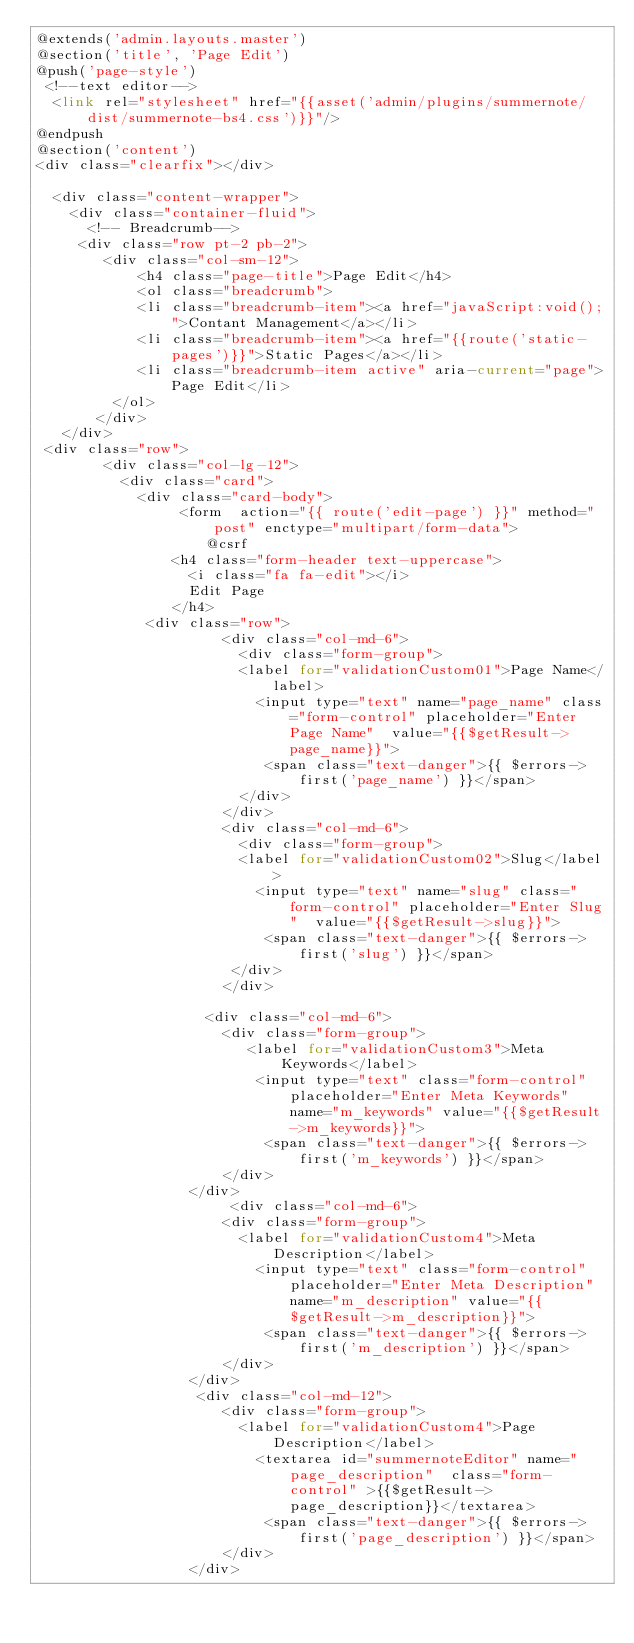Convert code to text. <code><loc_0><loc_0><loc_500><loc_500><_PHP_>@extends('admin.layouts.master')
@section('title', 'Page Edit')
@push('page-style')
 <!--text editor-->
  <link rel="stylesheet" href="{{asset('admin/plugins/summernote/dist/summernote-bs4.css')}}"/> 
@endpush
@section('content')
<div class="clearfix"></div>
	
  <div class="content-wrapper">
    <div class="container-fluid">
      <!-- Breadcrumb-->
     <div class="row pt-2 pb-2">
        <div class="col-sm-12">
		    <h4 class="page-title">Page Edit</h4>
		    <ol class="breadcrumb">
            <li class="breadcrumb-item"><a href="javaScript:void();">Contant Management</a></li>
            <li class="breadcrumb-item"><a href="{{route('static-pages')}}">Static Pages</a></li>
            <li class="breadcrumb-item active" aria-current="page">Page Edit</li>
         </ol>
	   </div>
   </div>
 <div class="row">
        <div class="col-lg-12">
          <div class="card">
            <div class="card-body">
                 <form  action="{{ route('edit-page') }}" method="post" enctype="multipart/form-data">
                    @csrf
                <h4 class="form-header text-uppercase">
                  <i class="fa fa-edit"></i>
                  Edit Page
                </h4>
             <div class="row">
                      <div class="col-md-6">
                        <div class="form-group">
                        <label for="validationCustom01">Page Name</label>
                          <input type="text" name="page_name" class="form-control" placeholder="Enter Page Name"  value="{{$getResult->page_name}}">
                           <span class="text-danger">{{ $errors->first('page_name') }}</span>
                        </div>
                      </div>
                      <div class="col-md-6">
                        <div class="form-group">
                        <label for="validationCustom02">Slug</label>
                          <input type="text" name="slug" class="form-control" placeholder="Enter Slug"  value="{{$getResult->slug}}">
                           <span class="text-danger">{{ $errors->first('slug') }}</span>
                       </div>
                      </div>
                  
                    <div class="col-md-6">
                      <div class="form-group">
                         <label for="validationCustom3">Meta Keywords</label>
                          <input type="text" class="form-control" placeholder="Enter Meta Keywords" name="m_keywords" value="{{$getResult->m_keywords}}">
                           <span class="text-danger">{{ $errors->first('m_keywords') }}</span>
                      </div>
                  </div>
                       <div class="col-md-6">
                      <div class="form-group">
                        <label for="validationCustom4">Meta Description</label>
                          <input type="text" class="form-control" placeholder="Enter Meta Description" name="m_description" value="{{$getResult->m_description}}">
                           <span class="text-danger">{{ $errors->first('m_description') }}</span>
                      </div>
                  </div>
                   <div class="col-md-12">
                      <div class="form-group">
                        <label for="validationCustom4">Page Description</label>
                          <textarea id="summernoteEditor" name="page_description"  class="form-control" >{{$getResult->page_description}}</textarea>
                           <span class="text-danger">{{ $errors->first('page_description') }}</span>
                      </div>
                  </div></code> 